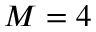<formula> <loc_0><loc_0><loc_500><loc_500>M = 4</formula> 